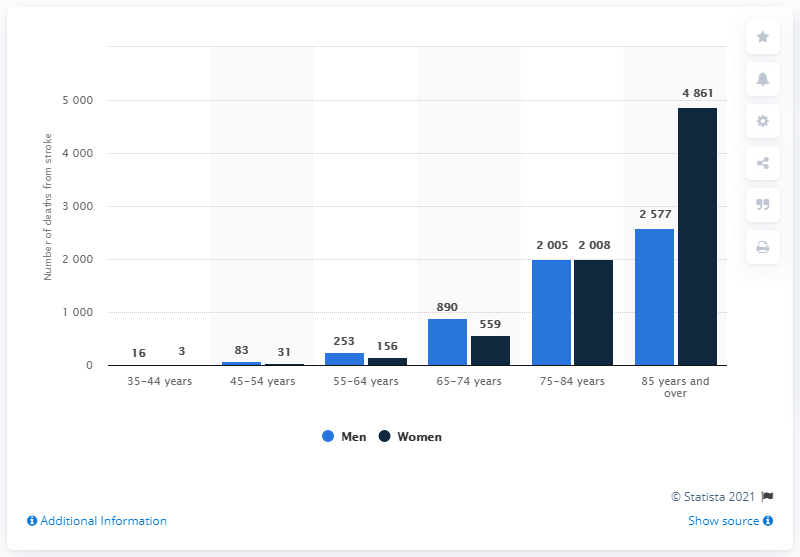Outline some significant characteristics in this image. The difference between the number of deaths of men and women in the age group of 35-44 years is the minimum. There were 890 men between the age group of 65-74 years who died as a result of stroke in the given time period. 